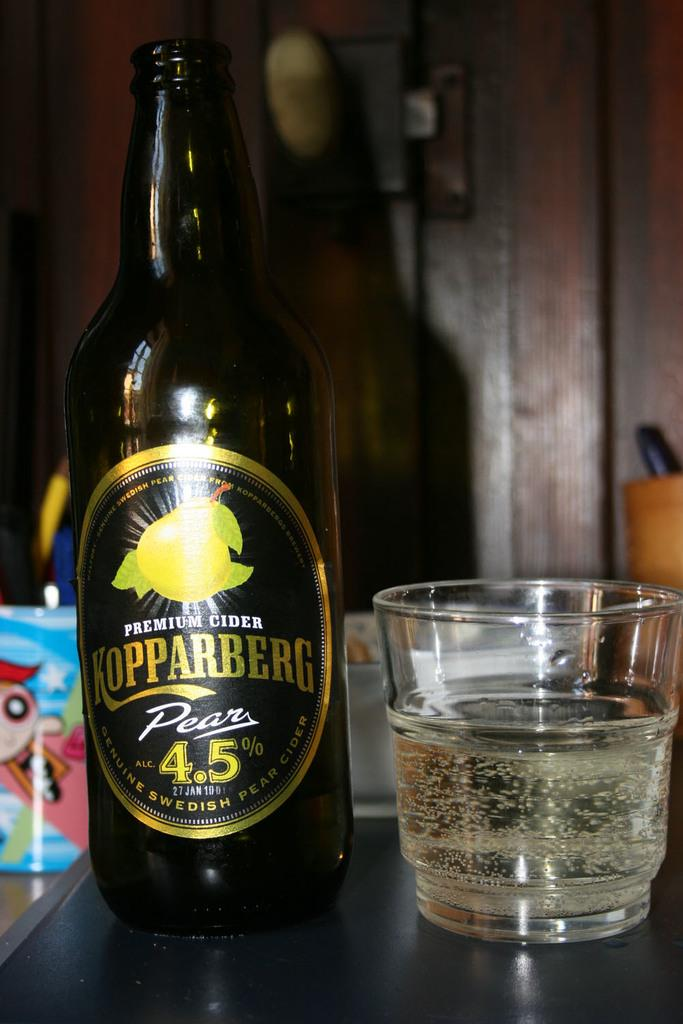<image>
Write a terse but informative summary of the picture. Tall bottle of beer saying it has 4.5% alc next to a cup. 